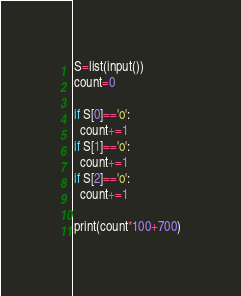Convert code to text. <code><loc_0><loc_0><loc_500><loc_500><_Python_>S=list(input())
count=0

if S[0]=='o':
  count+=1
if S[1]=='o':
  count+=1
if S[2]=='o':
  count+=1
  
print(count*100+700)</code> 